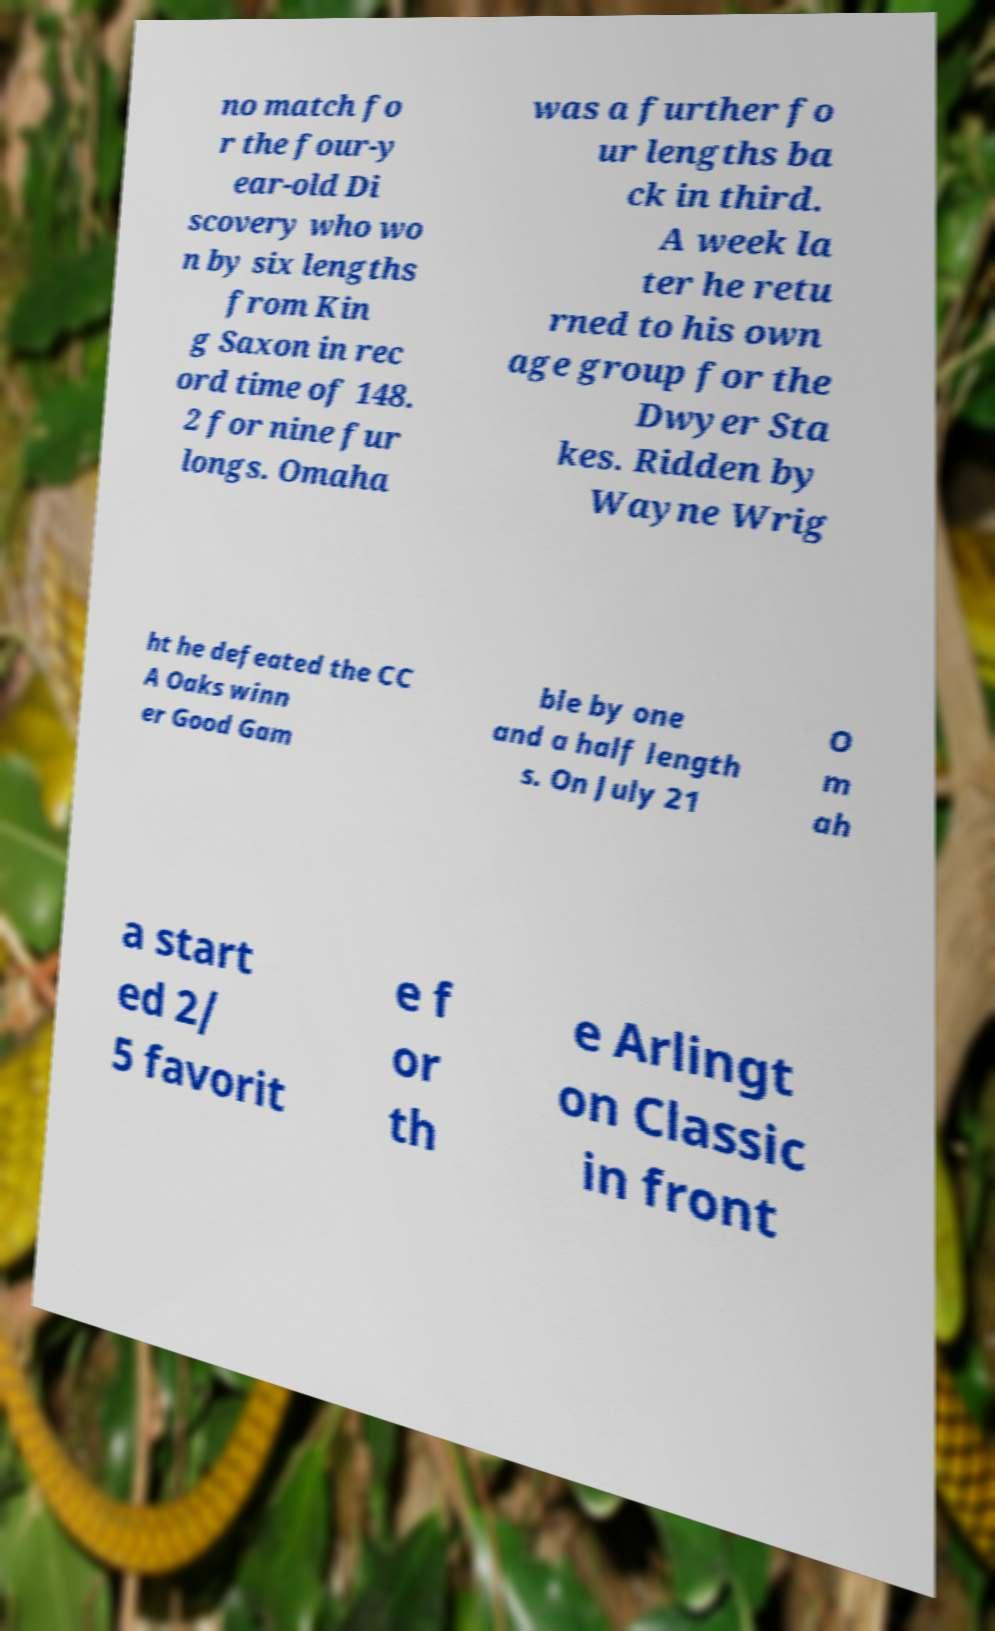Could you assist in decoding the text presented in this image and type it out clearly? no match fo r the four-y ear-old Di scovery who wo n by six lengths from Kin g Saxon in rec ord time of 148. 2 for nine fur longs. Omaha was a further fo ur lengths ba ck in third. A week la ter he retu rned to his own age group for the Dwyer Sta kes. Ridden by Wayne Wrig ht he defeated the CC A Oaks winn er Good Gam ble by one and a half length s. On July 21 O m ah a start ed 2/ 5 favorit e f or th e Arlingt on Classic in front 